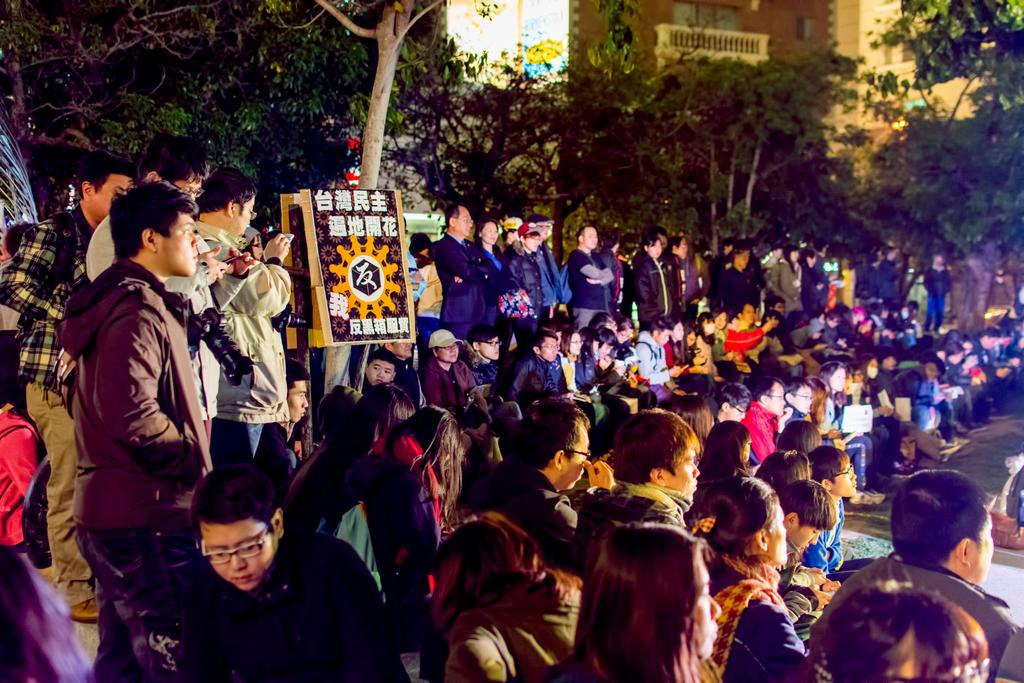How many people are in the image? There are persons in the image, but the exact number is not specified. What are the people in the image doing? Some of the persons are sitting, while others are standing. Where are the people located in the image? The persons are on the floor. What can be seen in the background of the image? There are trees and buildings in the background of the image. Reasoning: Let's think step by step by step in order to produce the conversation. We start by acknowledging the presence of persons in the image and then describe their positions (sitting and standing). Next, we mention their location (on the floor). Finally, we describe the background of the image, which includes trees and buildings. We avoid asking questions that cannot be answered definitively and ensure that the language is simple and clear. Absurd Question/Answer: Can you tell me how many leaves are on the goose in the image? There is no goose or leaves present in the image; it features persons on the floor with trees and buildings in the background. 